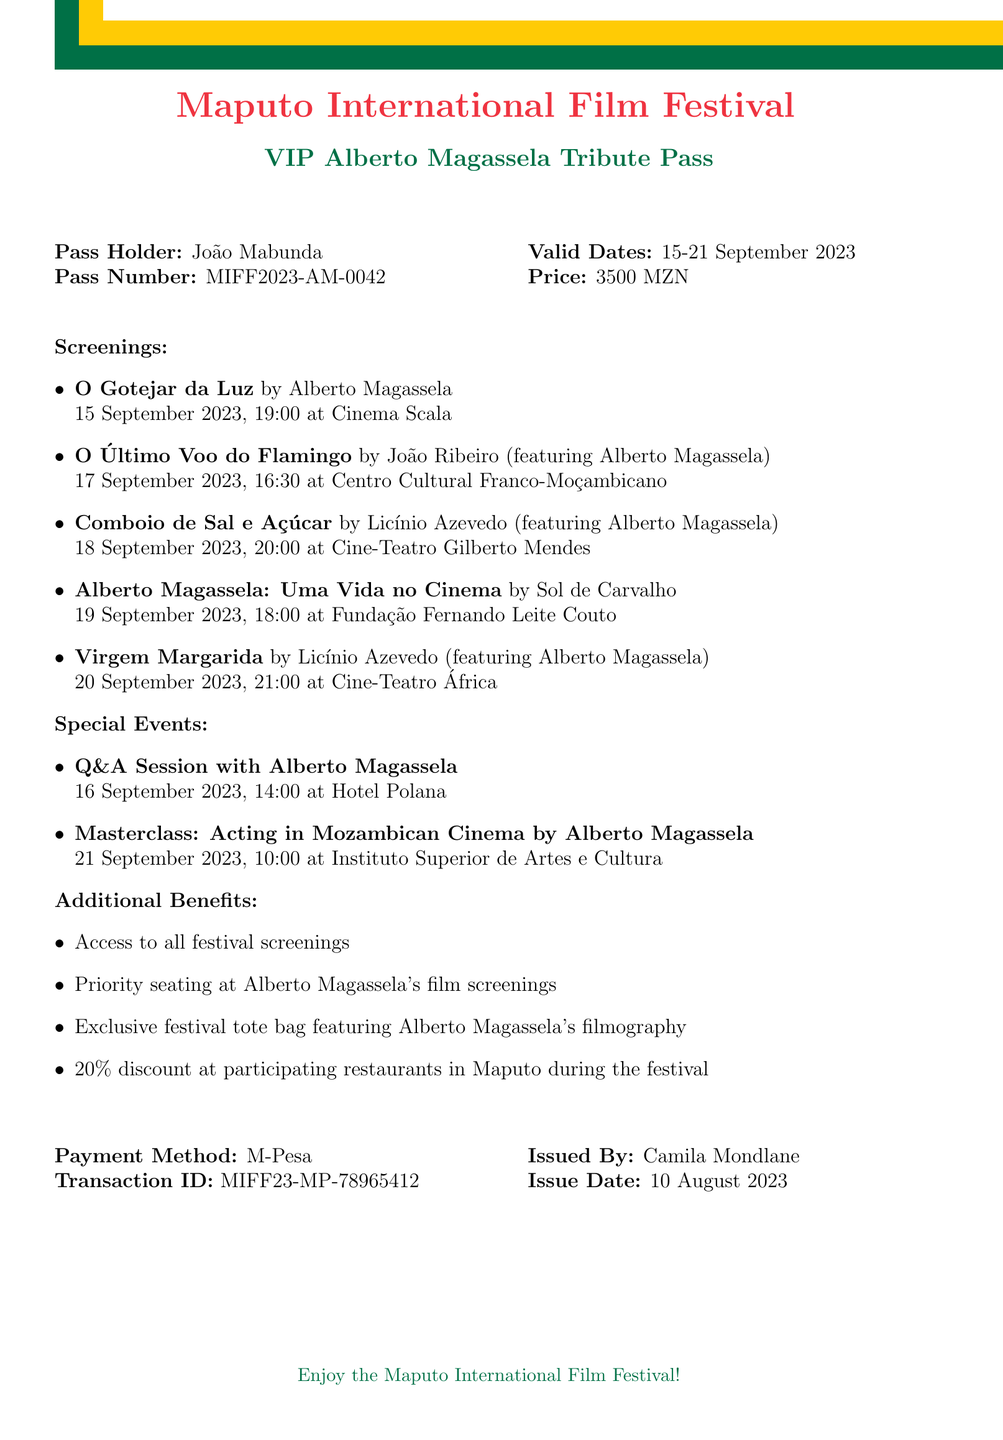What is the name of the film festival? The name of the film festival is mentioned at the top of the document.
Answer: Maputo International Film Festival Who is the pass holder? The pass holder's name is listed in the document.
Answer: João Mabunda What is the pass number? The pass number is specified in the document as a unique identifier for the pass.
Answer: MIFF2023-AM-0042 What are the valid dates for the pass? The valid dates are provided in a specific format in the document.
Answer: 15-21 September 2023 How much does the VIP pass cost? The price of the pass is indicated in the document.
Answer: 3500 MZN Which film is screening on 20 September 2023? The document lists the films along with their respective screening dates.
Answer: Virgem Margarida How many films are screened at the festival? The number of films can be counted from the screenings section of the document.
Answer: Five What special event occurs on 16 September 2023? The document lists special events along with their dates and descriptions.
Answer: Q&A Session with Alberto Magassela What method was used for payment? The payment method is clearly stated in the document.
Answer: M-Pesa 